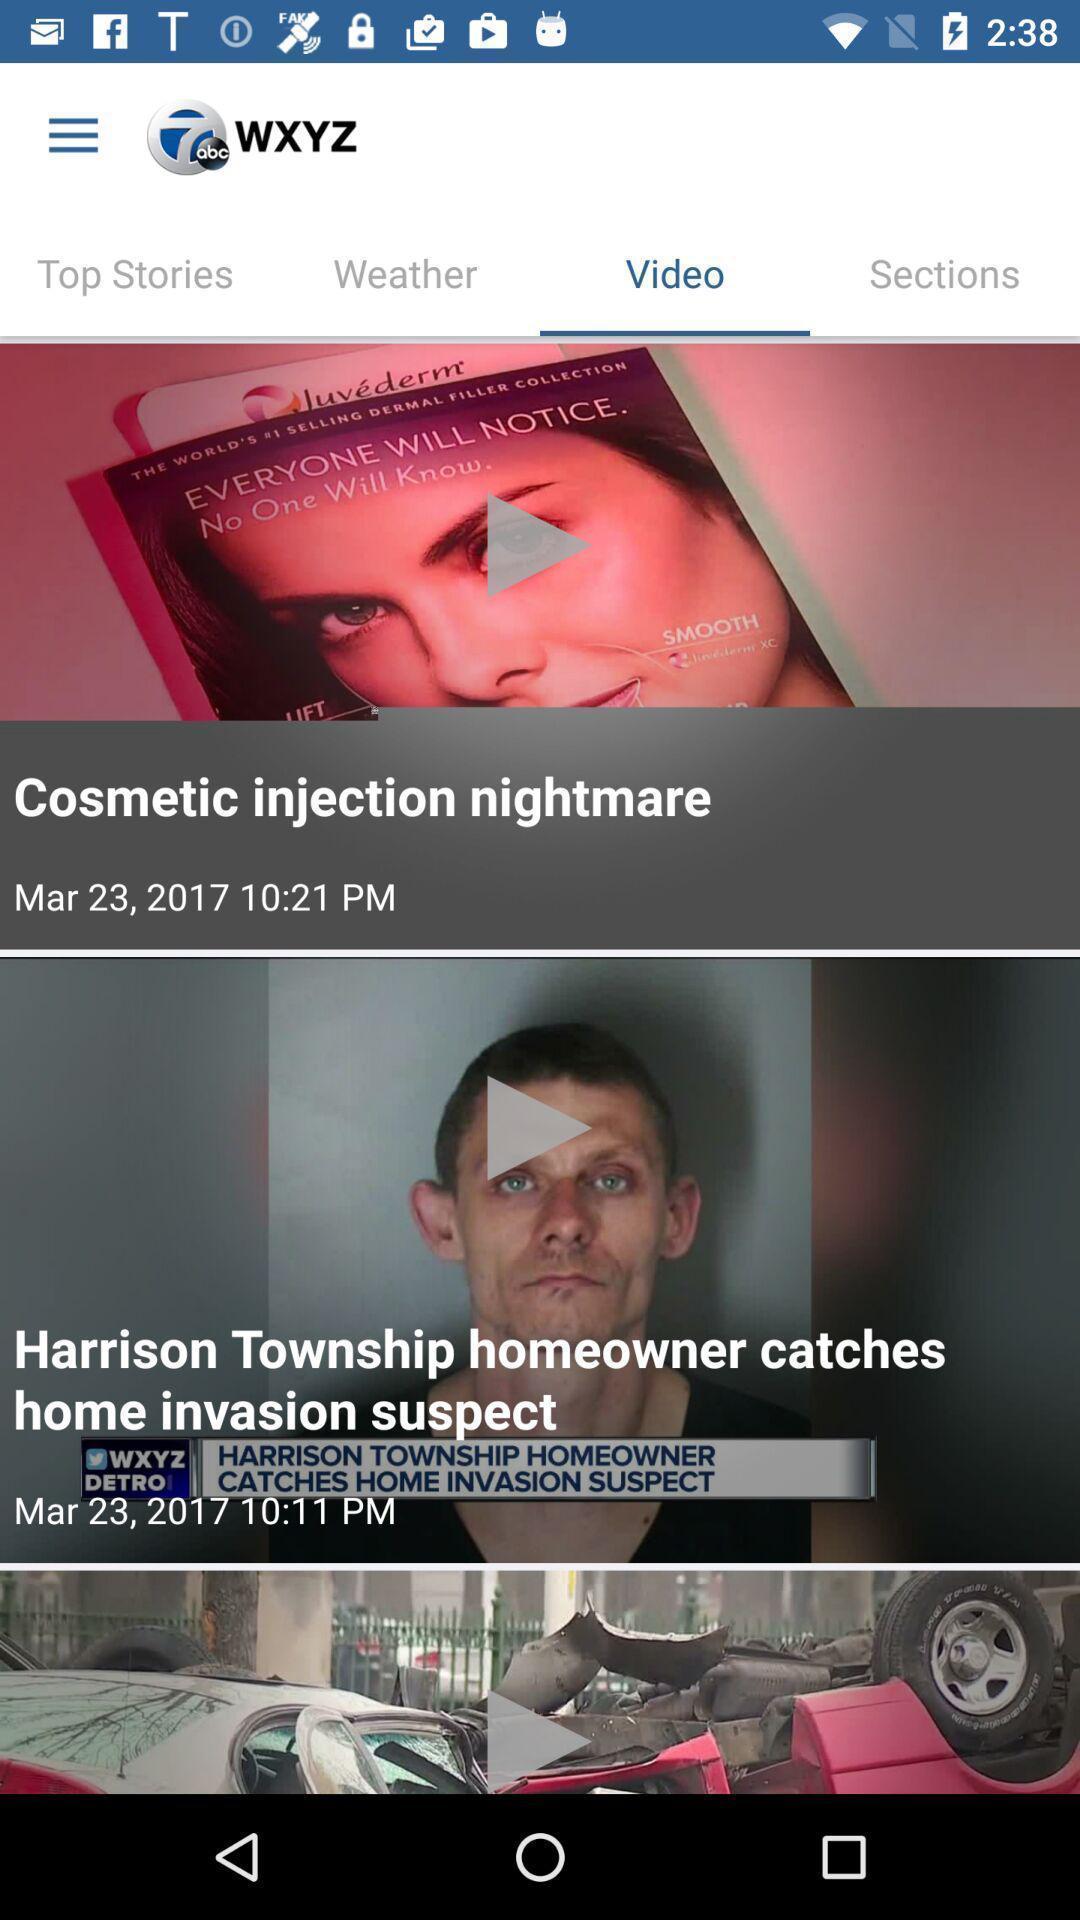Summarize the main components in this picture. Screen shows multiple videos in a news app. 